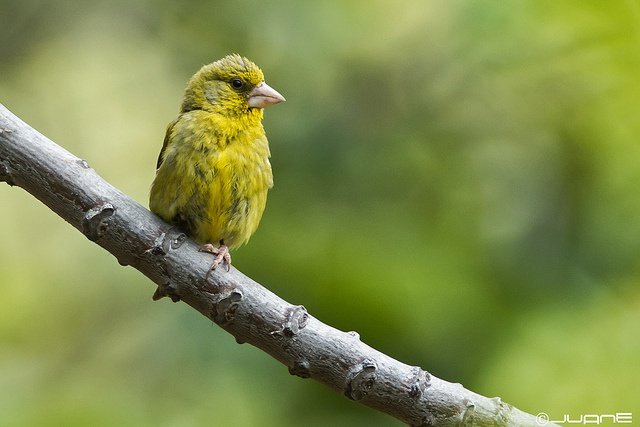Describe the objects in this image and their specific colors. I can see a bird in darkgreen, olive, and black tones in this image. 